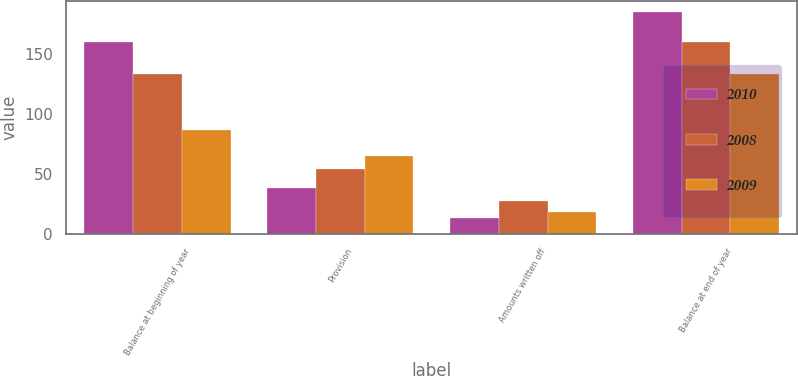<chart> <loc_0><loc_0><loc_500><loc_500><stacked_bar_chart><ecel><fcel>Balance at beginning of year<fcel>Provision<fcel>Amounts written off<fcel>Balance at end of year<nl><fcel>2010<fcel>160<fcel>38<fcel>13<fcel>185<nl><fcel>2008<fcel>133<fcel>54<fcel>27<fcel>160<nl><fcel>2009<fcel>86<fcel>65<fcel>18<fcel>133<nl></chart> 